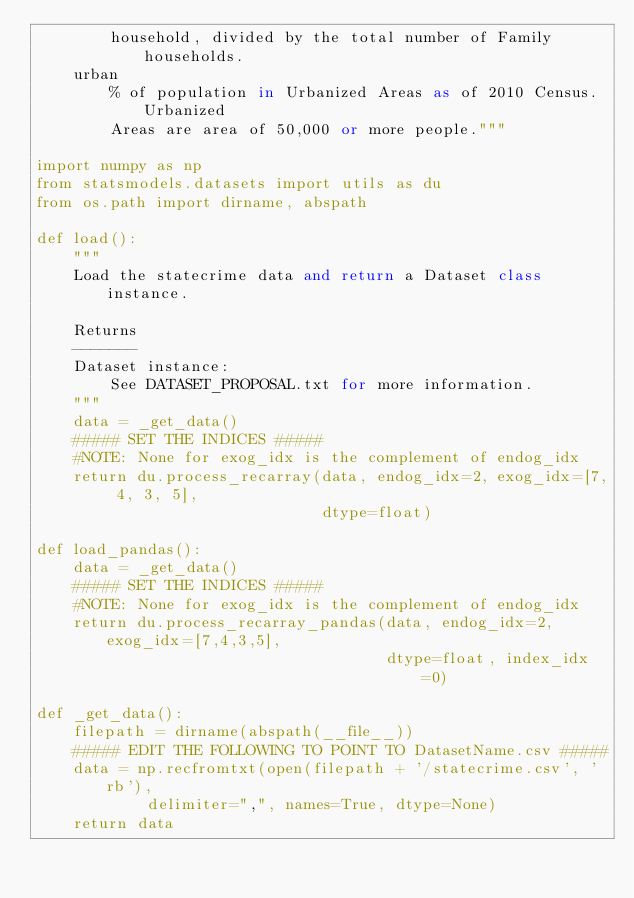Convert code to text. <code><loc_0><loc_0><loc_500><loc_500><_Python_>        household, divided by the total number of Family households.
    urban
        % of population in Urbanized Areas as of 2010 Census. Urbanized
        Areas are area of 50,000 or more people."""

import numpy as np
from statsmodels.datasets import utils as du
from os.path import dirname, abspath

def load():
    """
    Load the statecrime data and return a Dataset class instance.

    Returns
    -------
    Dataset instance:
        See DATASET_PROPOSAL.txt for more information.
    """
    data = _get_data()
    ##### SET THE INDICES #####
    #NOTE: None for exog_idx is the complement of endog_idx
    return du.process_recarray(data, endog_idx=2, exog_idx=[7, 4, 3, 5],
                               dtype=float)

def load_pandas():
    data = _get_data()
    ##### SET THE INDICES #####
    #NOTE: None for exog_idx is the complement of endog_idx
    return du.process_recarray_pandas(data, endog_idx=2, exog_idx=[7,4,3,5],
                                      dtype=float, index_idx=0)

def _get_data():
    filepath = dirname(abspath(__file__))
    ##### EDIT THE FOLLOWING TO POINT TO DatasetName.csv #####
    data = np.recfromtxt(open(filepath + '/statecrime.csv', 'rb'),
            delimiter=",", names=True, dtype=None)
    return data
</code> 